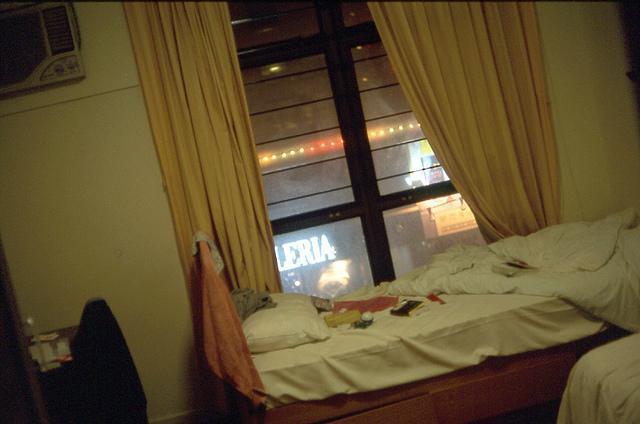How many pillows are on the bed?
Give a very brief answer. 1. How many pillows are there?
Give a very brief answer. 1. How many dolls are on the bed?
Give a very brief answer. 0. How many beds are visible?
Give a very brief answer. 2. 